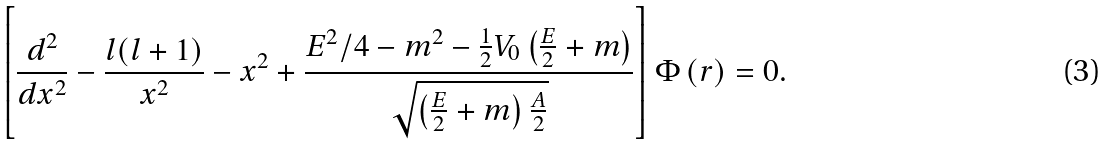Convert formula to latex. <formula><loc_0><loc_0><loc_500><loc_500>\left [ \frac { d ^ { 2 } } { d x ^ { 2 } } - \frac { l ( l + 1 ) } { x ^ { 2 } } - x ^ { 2 } + \frac { E ^ { 2 } / 4 - m ^ { 2 } - \frac { 1 } { 2 } V _ { 0 } \left ( \frac { E } { 2 } + m \right ) } { \sqrt { \left ( \frac { E } { 2 } + m \right ) \frac { A } { 2 } } } \right ] \Phi \left ( r \right ) = 0 .</formula> 